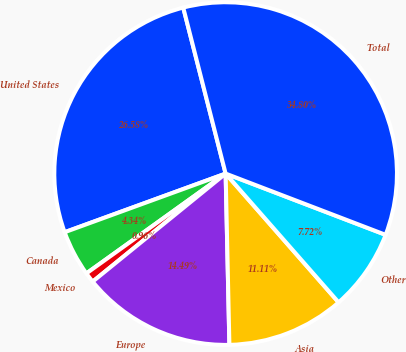Convert chart to OTSL. <chart><loc_0><loc_0><loc_500><loc_500><pie_chart><fcel>United States<fcel>Canada<fcel>Mexico<fcel>Europe<fcel>Asia<fcel>Other<fcel>Total<nl><fcel>26.58%<fcel>4.34%<fcel>0.96%<fcel>14.49%<fcel>11.11%<fcel>7.72%<fcel>34.8%<nl></chart> 